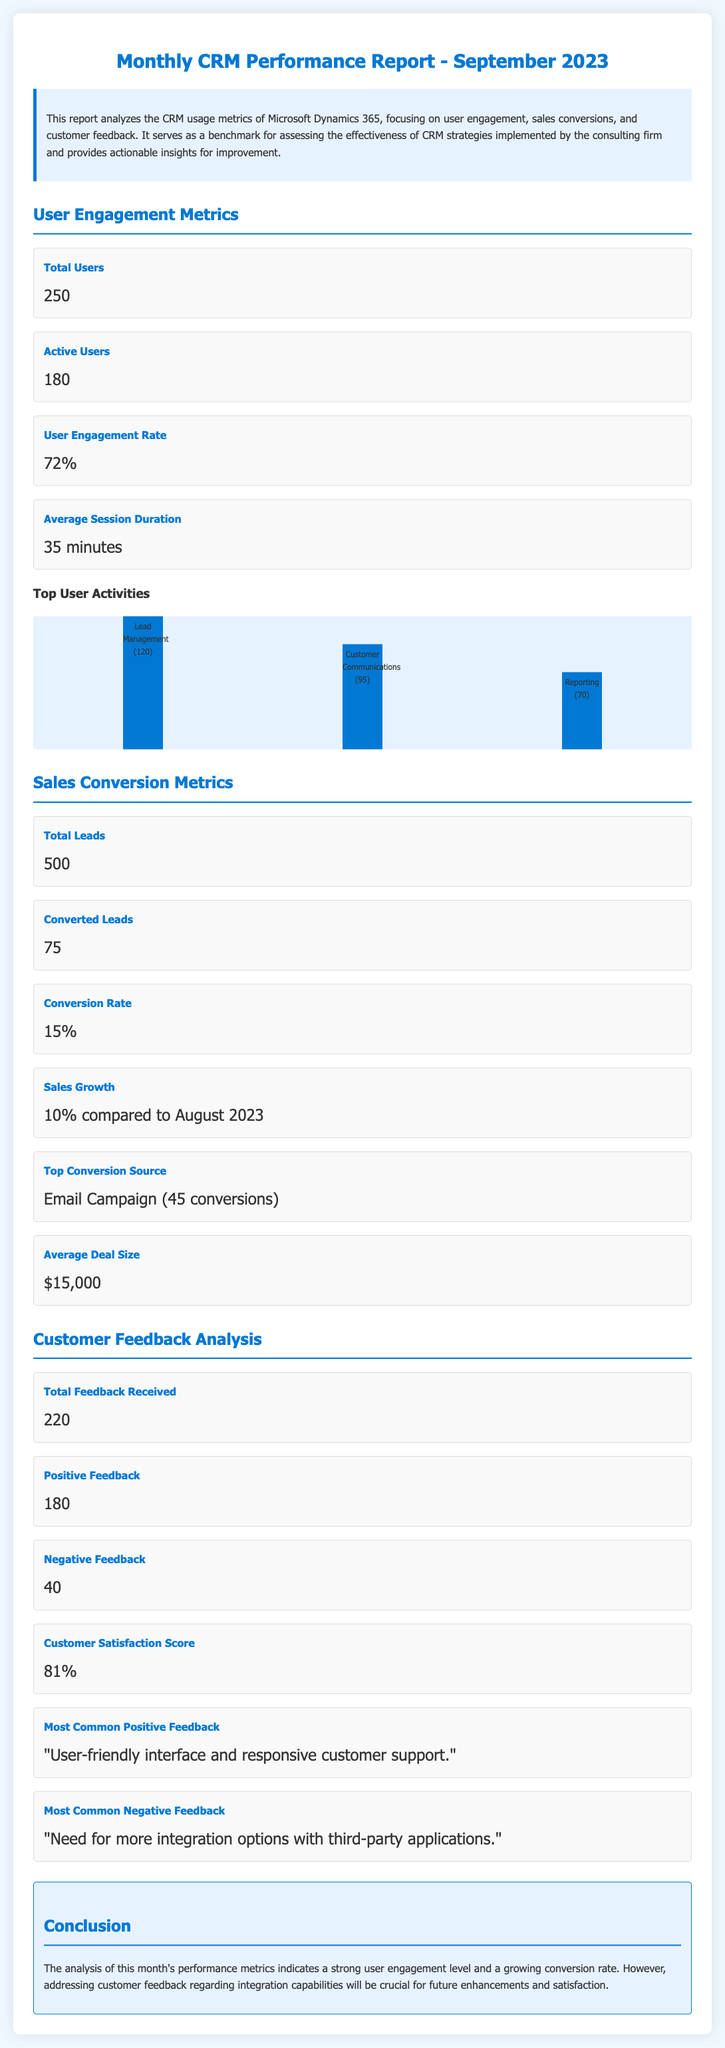What is the total number of users? The total number of users is explicitly stated in the user engagement metrics section.
Answer: 250 What is the user engagement rate? The user engagement rate is provided under the user engagement metrics section as a percentage.
Answer: 72% How many converted leads were reported? The number of converted leads is noted in the sales conversion metrics section of the report.
Answer: 75 What is the average deal size? The average deal size can be found in the sales conversion metrics section of the report.
Answer: $15,000 What is the customer satisfaction score? The customer satisfaction score is mentioned in the customer feedback analysis section of the report.
Answer: 81% How much did sales grow compared to August 2023? The sales growth compared to August 2023 is specifically mentioned in the sales conversion metrics.
Answer: 10% compared to August 2023 What feedback was most commonly received positively? The most common positive feedback is presented in the customer feedback analysis section.
Answer: "User-friendly interface and responsive customer support." What is the total feedback received? The total feedback received is a figure found within the customer feedback analysis section.
Answer: 220 What is the most common negative feedback? The most common negative feedback is reported in the customer feedback analysis section of the document.
Answer: "Need for more integration options with third-party applications." 